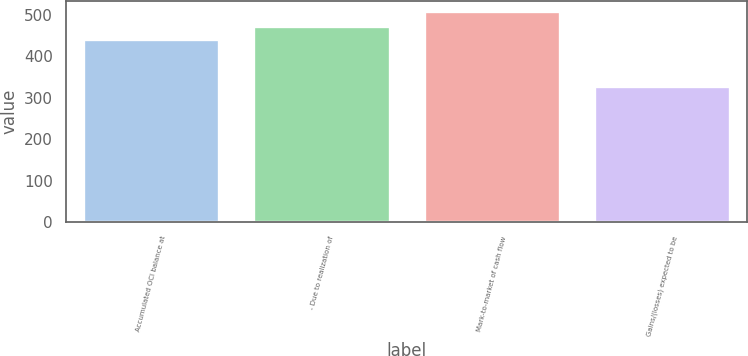Convert chart. <chart><loc_0><loc_0><loc_500><loc_500><bar_chart><fcel>Accumulated OCI balance at<fcel>- Due to realization of<fcel>Mark-to-market of cash flow<fcel>Gains/(losses) expected to be<nl><fcel>441<fcel>473<fcel>508<fcel>328<nl></chart> 